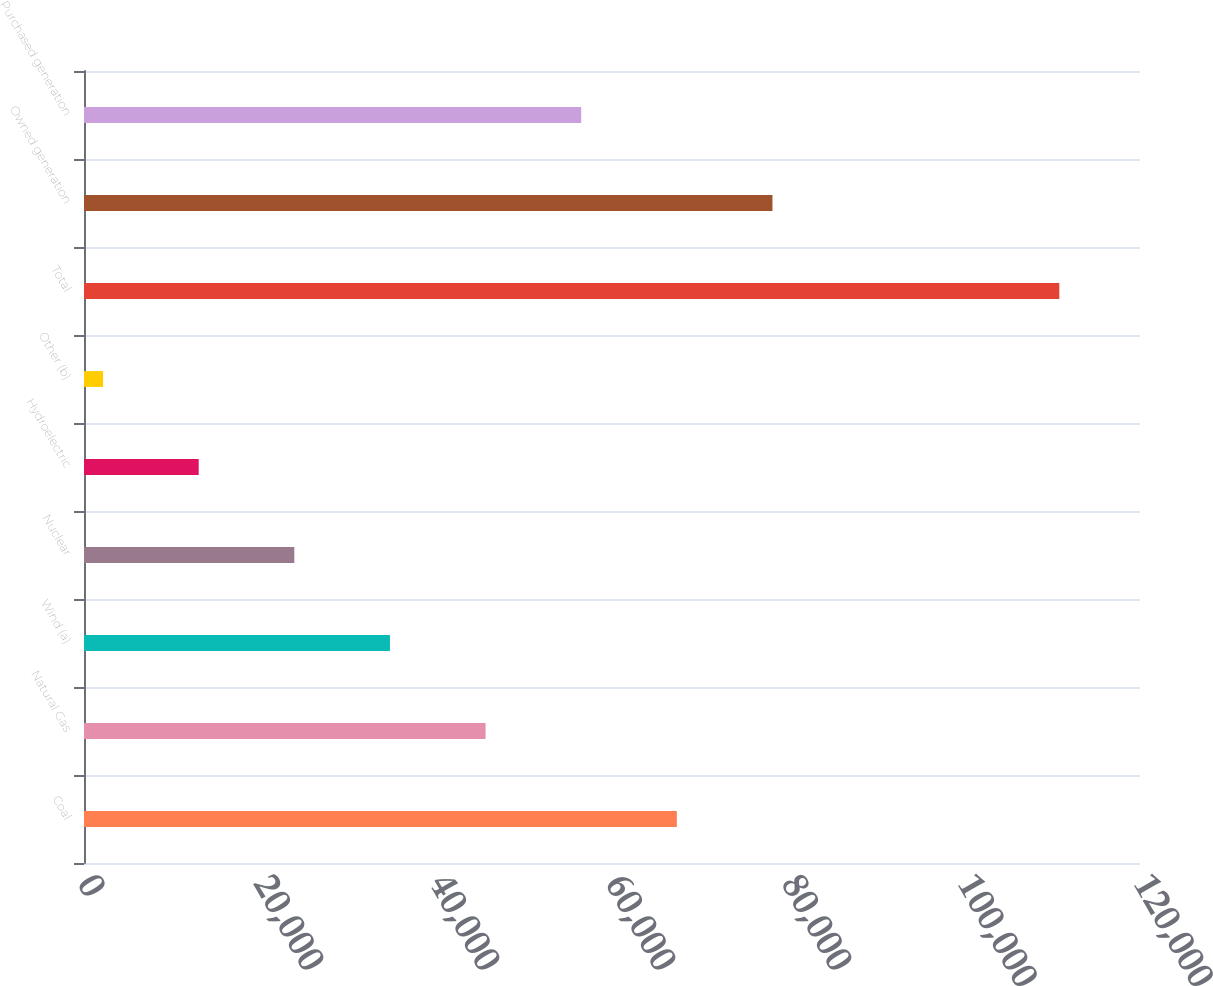Convert chart to OTSL. <chart><loc_0><loc_0><loc_500><loc_500><bar_chart><fcel>Coal<fcel>Natural Gas<fcel>Wind (a)<fcel>Nuclear<fcel>Hydroelectric<fcel>Other (b)<fcel>Total<fcel>Owned generation<fcel>Purchased generation<nl><fcel>67366.6<fcel>45633.4<fcel>34766.8<fcel>23900.2<fcel>13033.6<fcel>2167<fcel>110833<fcel>78233.2<fcel>56500<nl></chart> 